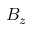Convert formula to latex. <formula><loc_0><loc_0><loc_500><loc_500>B _ { z }</formula> 